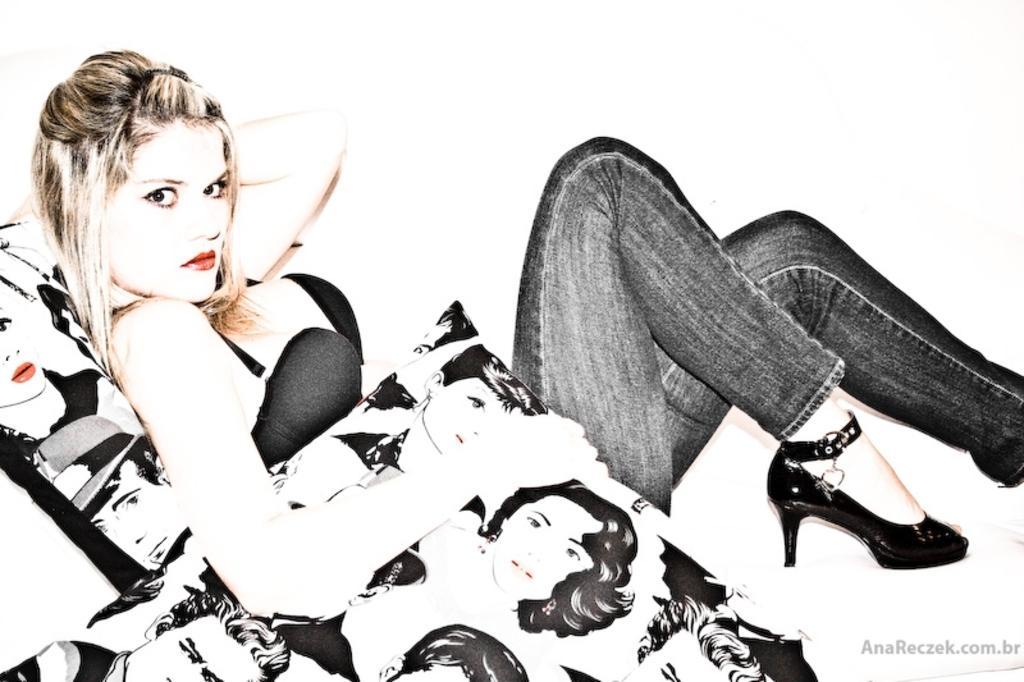Can you describe this image briefly? In this image we can see a lady sitting on the sofa and holding a cushion in her hand. 